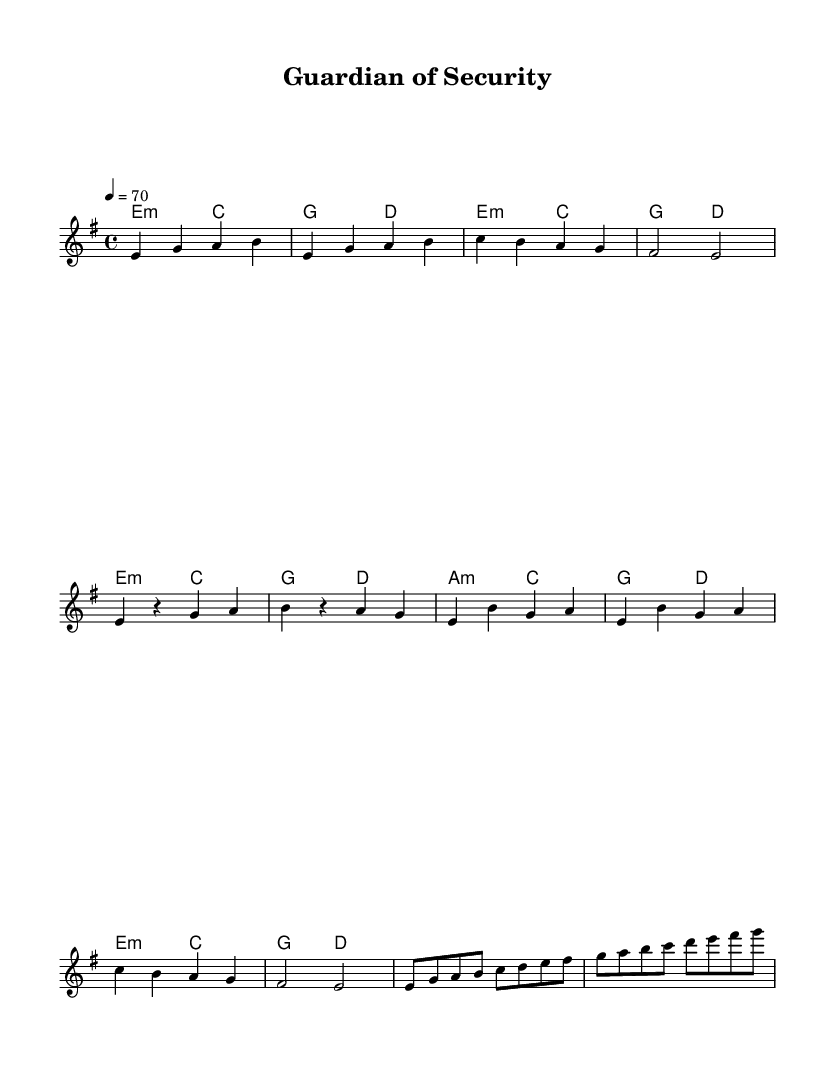What is the key signature of this music? The key signature is indicated at the very beginning of the sheet music. It specifies E minor, which has one sharp (F sharp).
Answer: E minor What is the time signature of the music? The time signature is shown at the beginning of the score, indicating that there are 4 beats in each measure. This is represented as 4/4.
Answer: 4/4 What tempo is indicated for this piece? The tempo marking appears at the start of the score, stating that the piece should be played at a speed of 70 beats per minute.
Answer: 70 What chords are used in the intro section? The intro section of the music includes a progression of two chords: E minor and C major, as shown in the harmonies section.
Answer: E minor, C major What is the pattern of the verse in terms of note repetitions? In the verse section, the notes consist of a pattern alternating between E and G with a rhythmic pause, reflecting typical structure in metal ballads that emphasizes emotional delivery.
Answer: E, G How many different chords are used in the chorus? The chorus features four unique chords, which are E minor, C major, G major, and A minor, as noted in the score.
Answer: Four What is unique about this piece in the context of metal music? This piece incorporates the hallmark features of power metal ballads, combining melodic lines with emotional lyrics around the theme of heroism in the insurance industry, a unique narrative context for this genre.
Answer: Heroism in insurance 